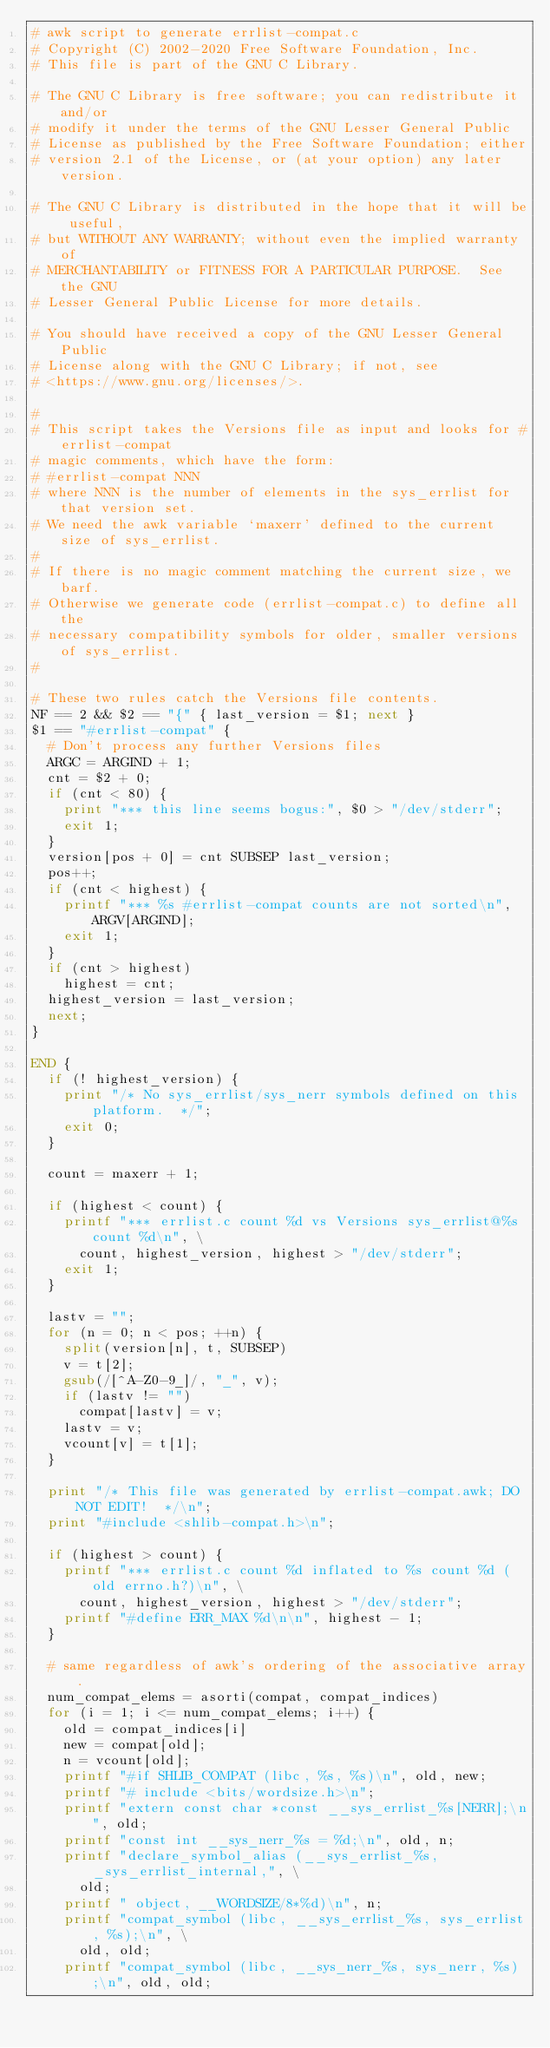<code> <loc_0><loc_0><loc_500><loc_500><_Awk_># awk script to generate errlist-compat.c
# Copyright (C) 2002-2020 Free Software Foundation, Inc.
# This file is part of the GNU C Library.

# The GNU C Library is free software; you can redistribute it and/or
# modify it under the terms of the GNU Lesser General Public
# License as published by the Free Software Foundation; either
# version 2.1 of the License, or (at your option) any later version.

# The GNU C Library is distributed in the hope that it will be useful,
# but WITHOUT ANY WARRANTY; without even the implied warranty of
# MERCHANTABILITY or FITNESS FOR A PARTICULAR PURPOSE.  See the GNU
# Lesser General Public License for more details.

# You should have received a copy of the GNU Lesser General Public
# License along with the GNU C Library; if not, see
# <https://www.gnu.org/licenses/>.

#
# This script takes the Versions file as input and looks for #errlist-compat
# magic comments, which have the form:
#	#errlist-compat NNN
# where NNN is the number of elements in the sys_errlist for that version set.
# We need the awk variable `maxerr' defined to the current size of sys_errlist.
#
# If there is no magic comment matching the current size, we barf.
# Otherwise we generate code (errlist-compat.c) to define all the
# necessary compatibility symbols for older, smaller versions of sys_errlist.
#

# These two rules catch the Versions file contents.
NF == 2 && $2 == "{" { last_version = $1; next }
$1 == "#errlist-compat" {
  # Don't process any further Versions files
  ARGC = ARGIND + 1;
  cnt = $2 + 0;
  if (cnt < 80) {
    print "*** this line seems bogus:", $0 > "/dev/stderr";
    exit 1;
  }
  version[pos + 0] = cnt SUBSEP last_version;
  pos++;
  if (cnt < highest) {
    printf "*** %s #errlist-compat counts are not sorted\n", ARGV[ARGIND];
    exit 1;
  }
  if (cnt > highest)
    highest = cnt;
  highest_version = last_version;
  next;
}

END {
  if (! highest_version) {
    print "/* No sys_errlist/sys_nerr symbols defined on this platform.  */";
    exit 0;
  }

  count = maxerr + 1;

  if (highest < count) {
    printf "*** errlist.c count %d vs Versions sys_errlist@%s count %d\n", \
      count, highest_version, highest > "/dev/stderr";
    exit 1;
  }

  lastv = "";
  for (n = 0; n < pos; ++n) {
    split(version[n], t, SUBSEP)
    v = t[2];
    gsub(/[^A-Z0-9_]/, "_", v);
    if (lastv != "")
      compat[lastv] = v;
    lastv = v;
    vcount[v] = t[1];
  }

  print "/* This file was generated by errlist-compat.awk; DO NOT EDIT!  */\n";
  print "#include <shlib-compat.h>\n";

  if (highest > count) {
    printf "*** errlist.c count %d inflated to %s count %d (old errno.h?)\n", \
      count, highest_version, highest > "/dev/stderr";
    printf "#define ERR_MAX %d\n\n", highest - 1;
  }

  # same regardless of awk's ordering of the associative array.
  num_compat_elems = asorti(compat, compat_indices)
  for (i = 1; i <= num_compat_elems; i++) {
    old = compat_indices[i]
    new = compat[old];
    n = vcount[old];
    printf "#if SHLIB_COMPAT (libc, %s, %s)\n", old, new;
    printf "# include <bits/wordsize.h>\n";
    printf "extern const char *const __sys_errlist_%s[NERR];\n", old;
    printf "const int __sys_nerr_%s = %d;\n", old, n;
    printf "declare_symbol_alias (__sys_errlist_%s, _sys_errlist_internal,", \
      old;
    printf " object, __WORDSIZE/8*%d)\n", n;
    printf "compat_symbol (libc, __sys_errlist_%s, sys_errlist, %s);\n", \
      old, old;
    printf "compat_symbol (libc, __sys_nerr_%s, sys_nerr, %s);\n", old, old;
</code> 